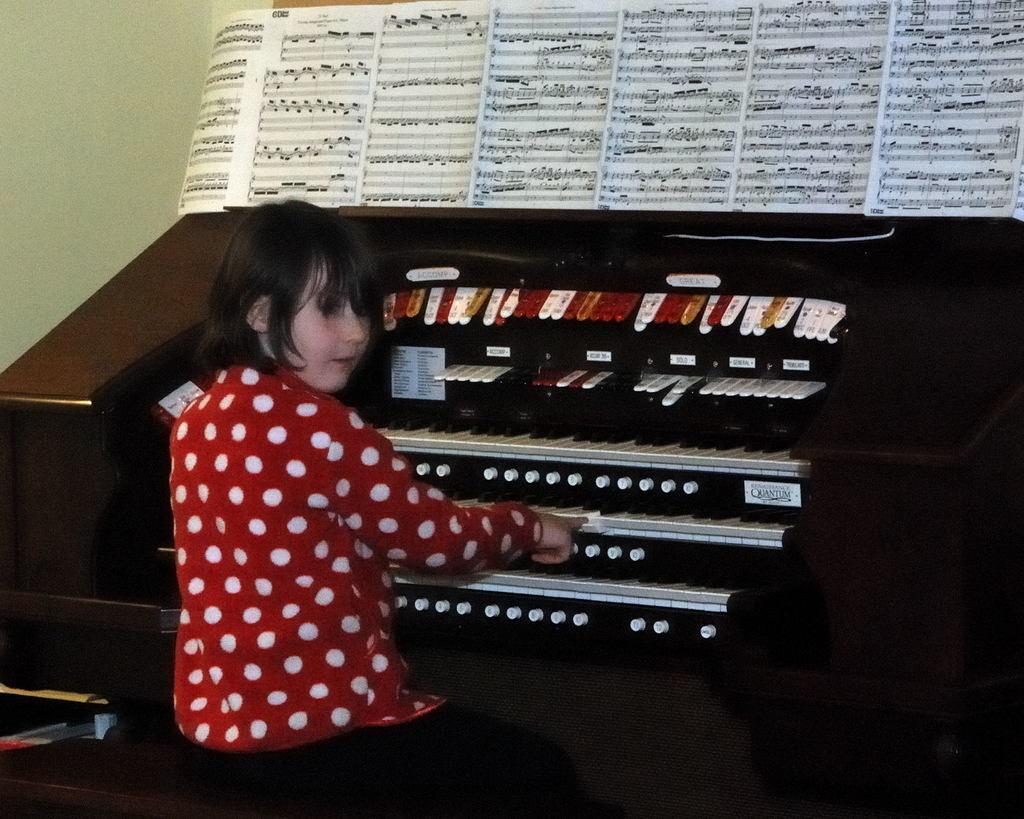Could you give a brief overview of what you see in this image? In this Image I see a girl who is sitting in front of a piano and she is playing, I can also see there are books on the piano and I see the green colored wall. 